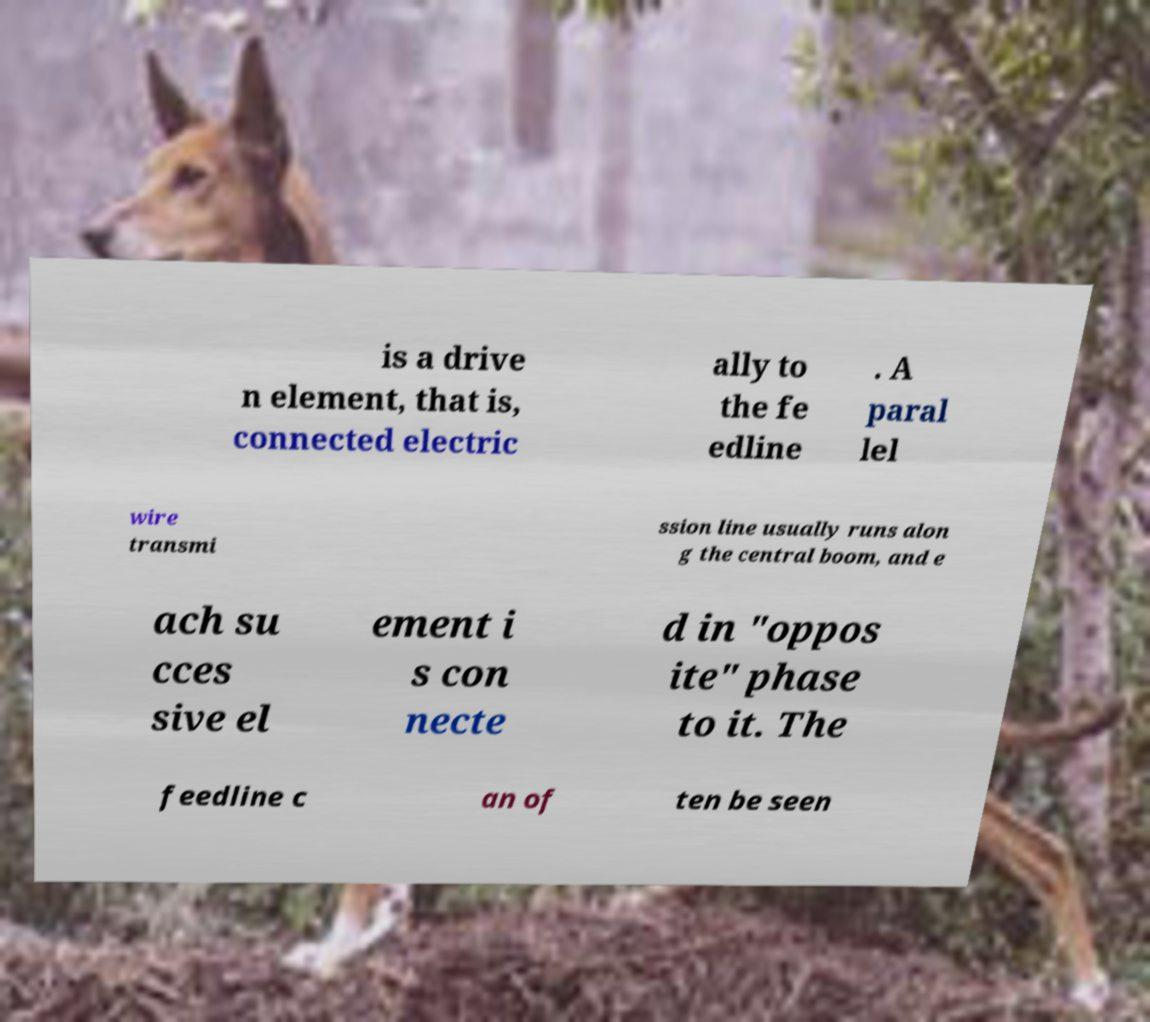Can you read and provide the text displayed in the image?This photo seems to have some interesting text. Can you extract and type it out for me? is a drive n element, that is, connected electric ally to the fe edline . A paral lel wire transmi ssion line usually runs alon g the central boom, and e ach su cces sive el ement i s con necte d in "oppos ite" phase to it. The feedline c an of ten be seen 